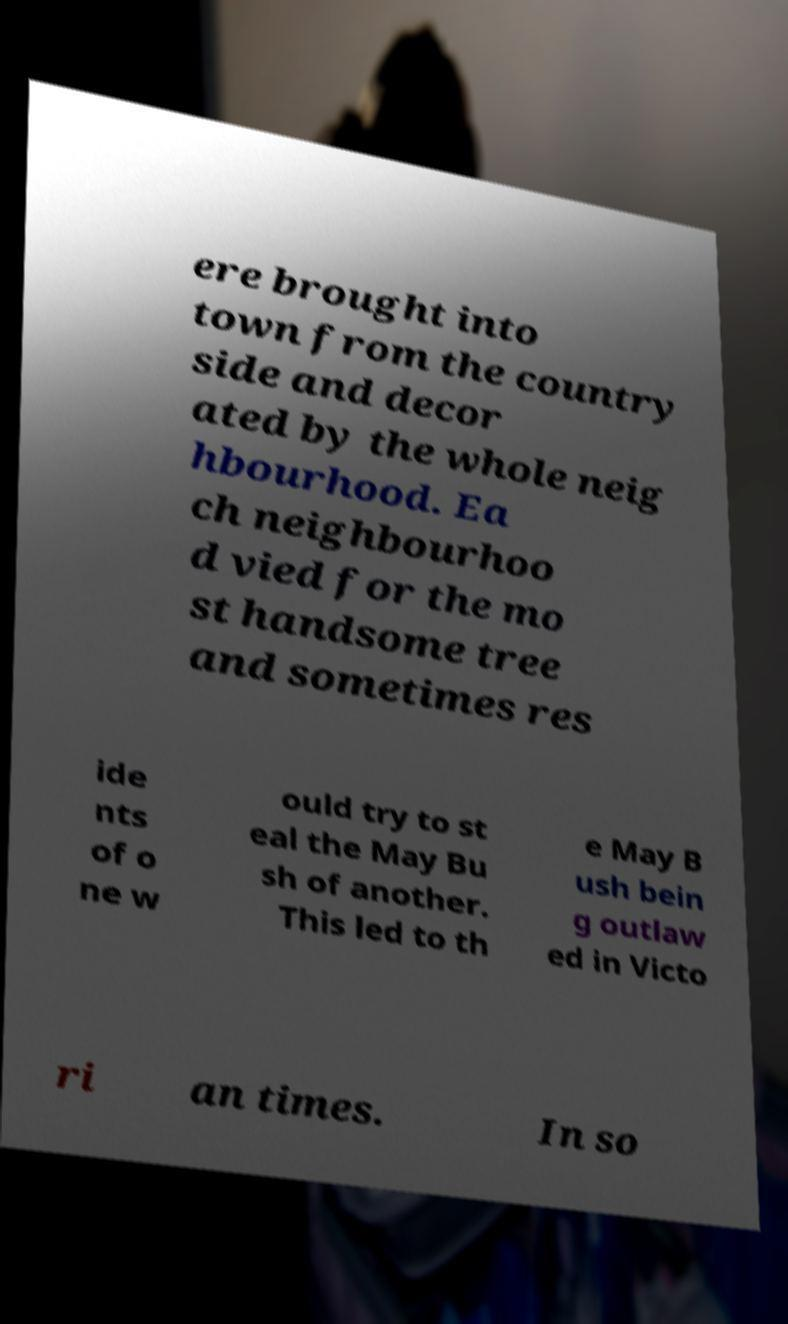Could you assist in decoding the text presented in this image and type it out clearly? ere brought into town from the country side and decor ated by the whole neig hbourhood. Ea ch neighbourhoo d vied for the mo st handsome tree and sometimes res ide nts of o ne w ould try to st eal the May Bu sh of another. This led to th e May B ush bein g outlaw ed in Victo ri an times. In so 